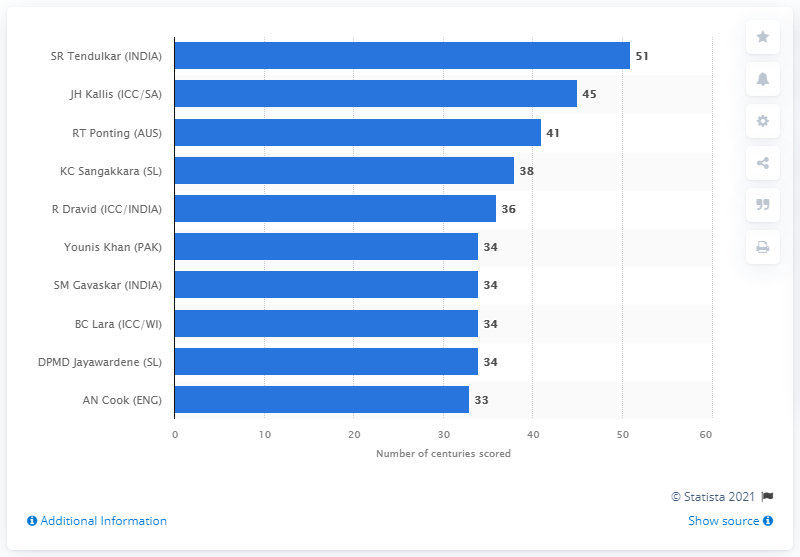Point out several critical features in this image. Sachin Tendulkar scored a total of 51 centuries in his test match career, which lasted for a total of 24 years and 20 days. 